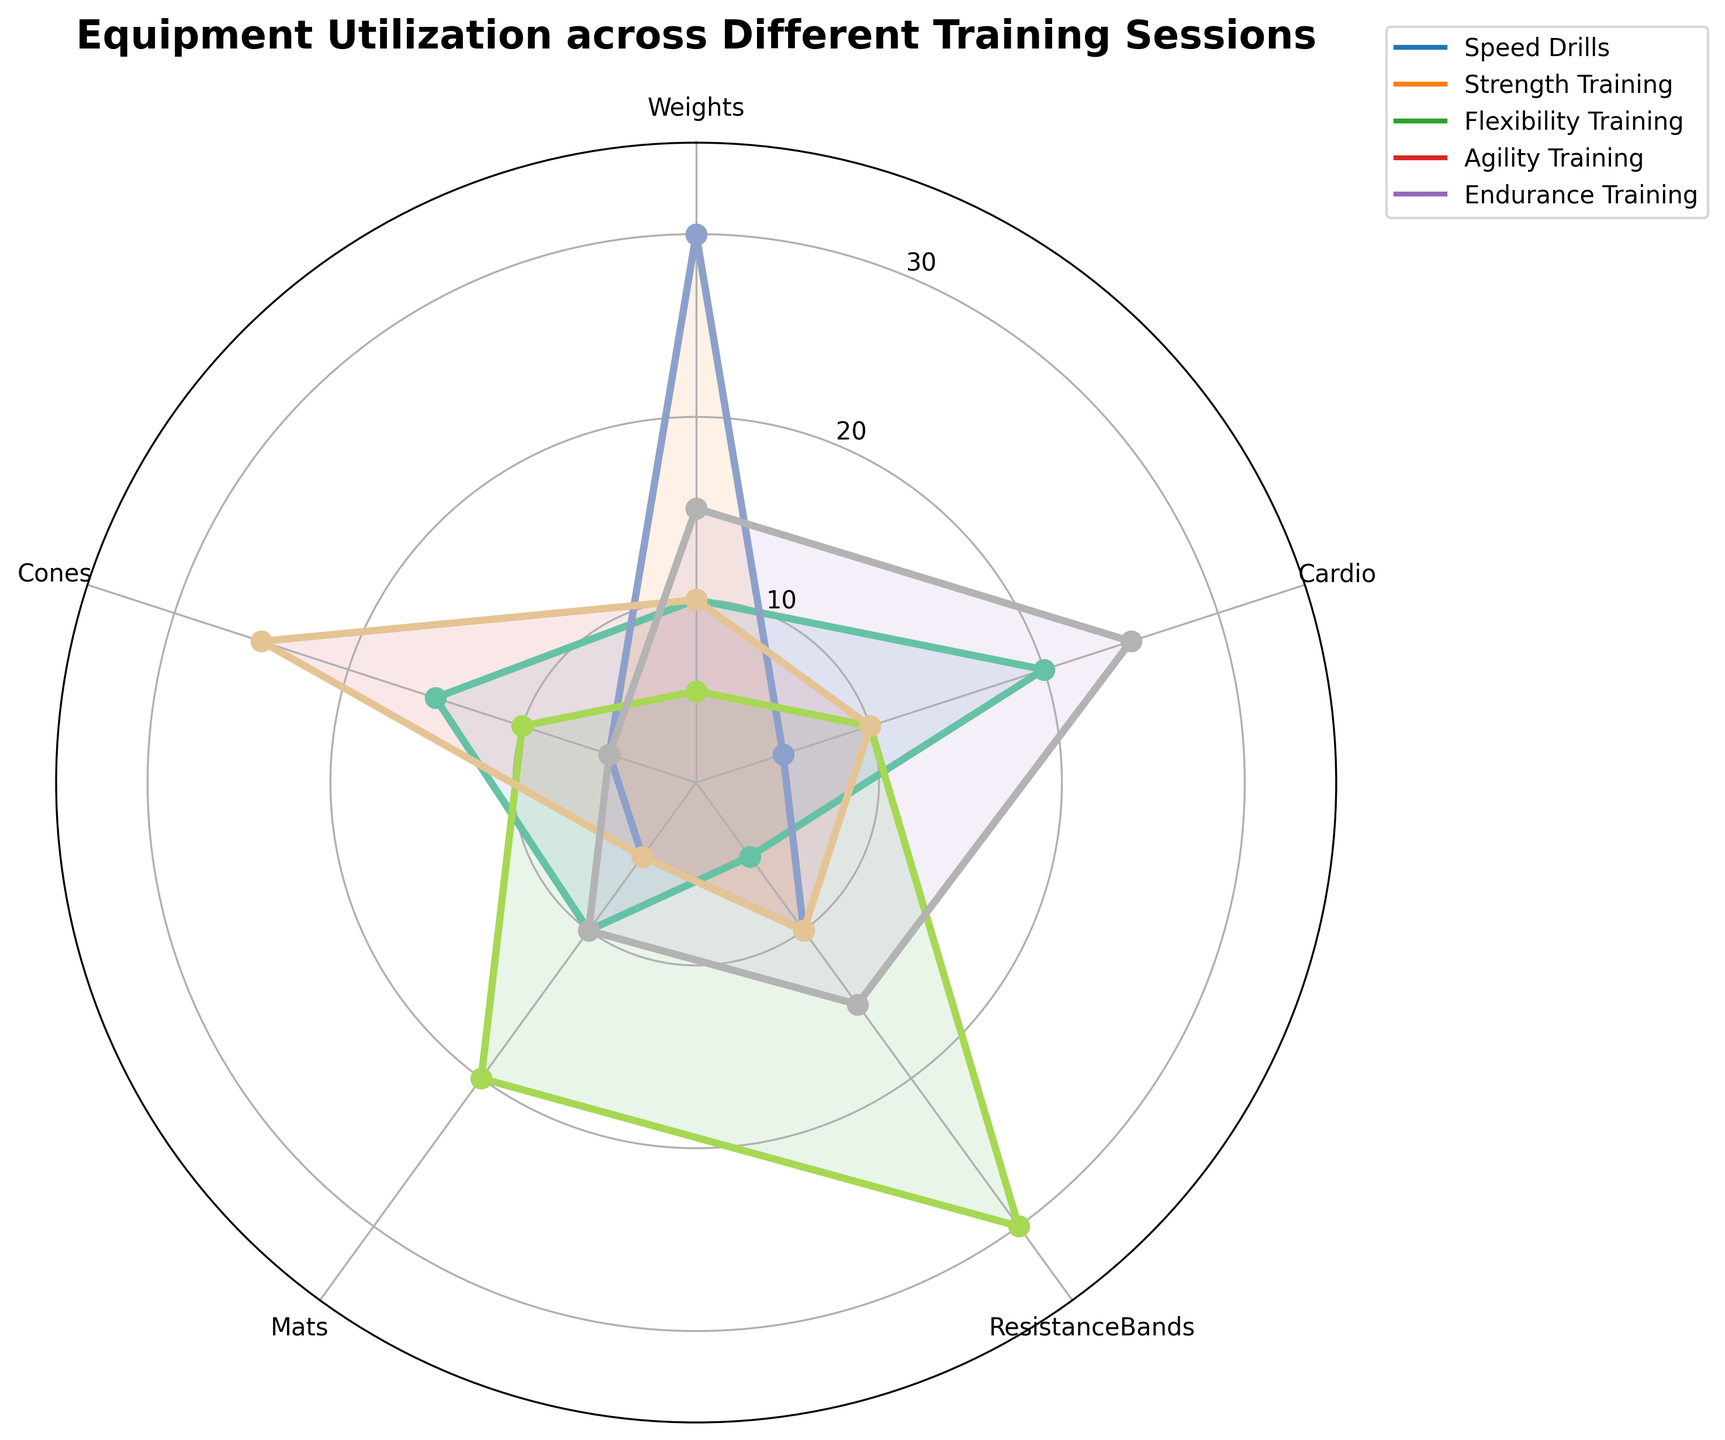What's the title of the radar chart? The title of the radar chart is usually placed at the top center of the figure. By visually inspecting this area, you can confirm the exact wording.
Answer: "Equipment Utilization across Different Training Sessions" How many training sessions are compared in the radar chart? The radar chart has multiple lines, each representing a different training session. By counting the distinct lines and their labels in the legend, you can determine the number of training sessions.
Answer: 5 Which equipment is utilized the most in "Strength Training"? In the "Strength Training" session, we observe the length of each spoke corresponding to different equipment. The longest spoke indicates the most utilized equipment.
Answer: Weights Does "Flexibility Training" use more "Mats" or "Cones"? By comparing the lengths of the spokes for "Mats" and "Cones" within the "Flexibility Training" line, we can see which one extends further.
Answer: Mats Which training session uses the least amount of "Cardio" equipment? To determine this, check the shortest spoke or point on the radar chart for the "Cardio" equipment across all training sessions.
Answer: Strength Training What is the sum of "Weights" utilization across all training sessions? Add the values of "Weights" from each training session: Speed Drills (10), Strength Training (30), Flexibility Training (5), Agility Training (10), Endurance Training (15). Thus, 10 + 30 + 5 + 10 + 15.
Answer: 70 How does the utilization of "Cones" in "Agility Training" compare to that in "Endurance Training"? Observe the lengths of the spokes for "Cones" in "Agility Training" and "Endurance Training." The one that extends further denotes higher utilization.
Answer: Agility Training uses more Cones than Endurance Training Is the total utilization of "Weights" and "Mats" in "Speed Drills" greater than 20? Add the values for "Weights" (10) and "Mats" (10) in "Speed Drills" and compare the sum to 20. Thus, 10 + 10 > 20.
Answer: No Which training session has the most balanced equipment utilization across categories? A balanced utilization would show a more circular or evenly distributed line on the radar chart. Examine the lines and determine which one doesn't have extreme peaks or troughs.
Answer: Agility Training What is the percentage difference in "Cardio" utilization between "Speed Drills" and "Endurance Training"? Subtract the "Cardio" value for Speed Drills (20) from the value for Endurance Training (25), divide the difference by the value for Speed Drills, and multiply by 100 to get the percentage. Thus, ((25 - 20) / 20) * 100.
Answer: 25% 